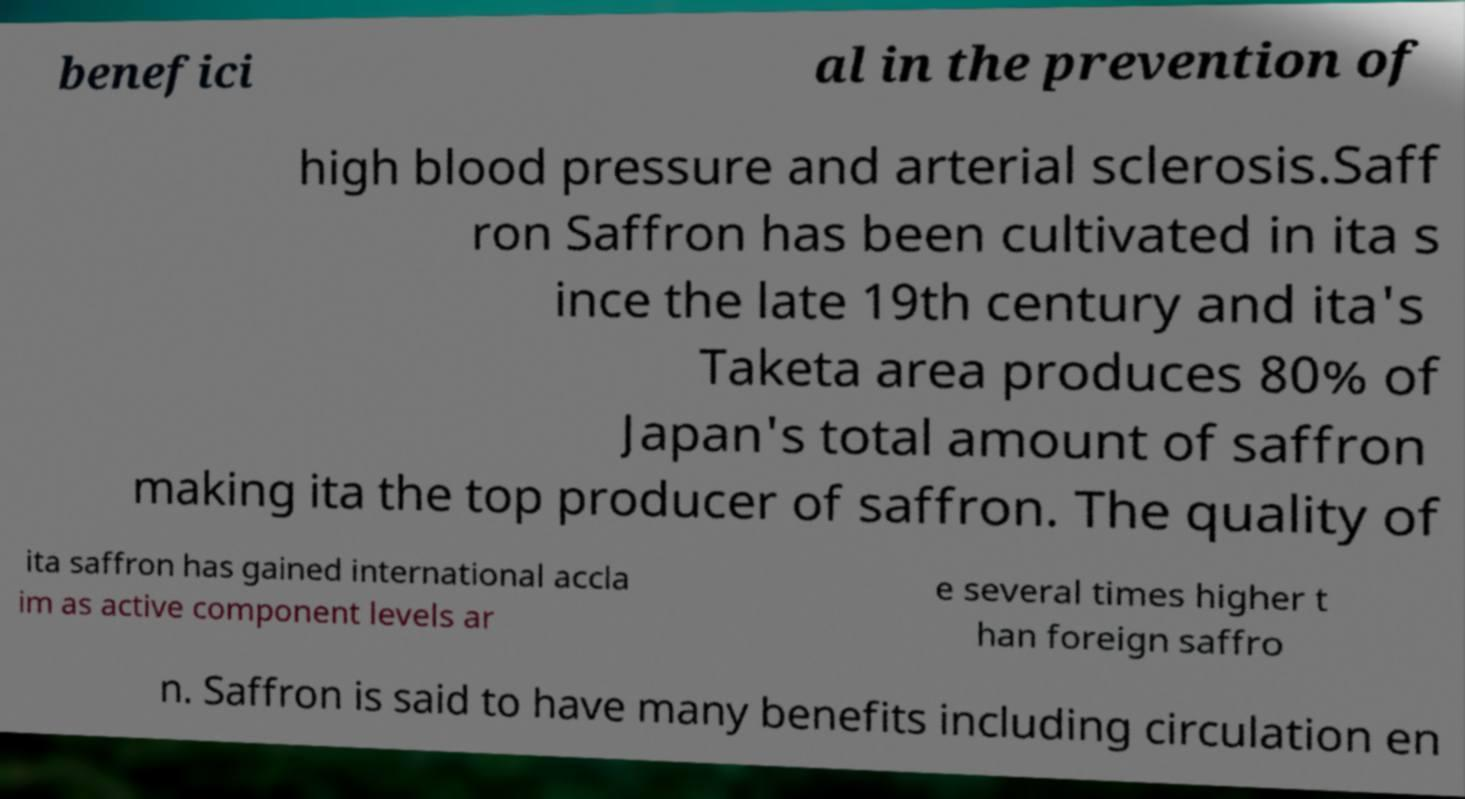There's text embedded in this image that I need extracted. Can you transcribe it verbatim? benefici al in the prevention of high blood pressure and arterial sclerosis.Saff ron Saffron has been cultivated in ita s ince the late 19th century and ita's Taketa area produces 80% of Japan's total amount of saffron making ita the top producer of saffron. The quality of ita saffron has gained international accla im as active component levels ar e several times higher t han foreign saffro n. Saffron is said to have many benefits including circulation en 